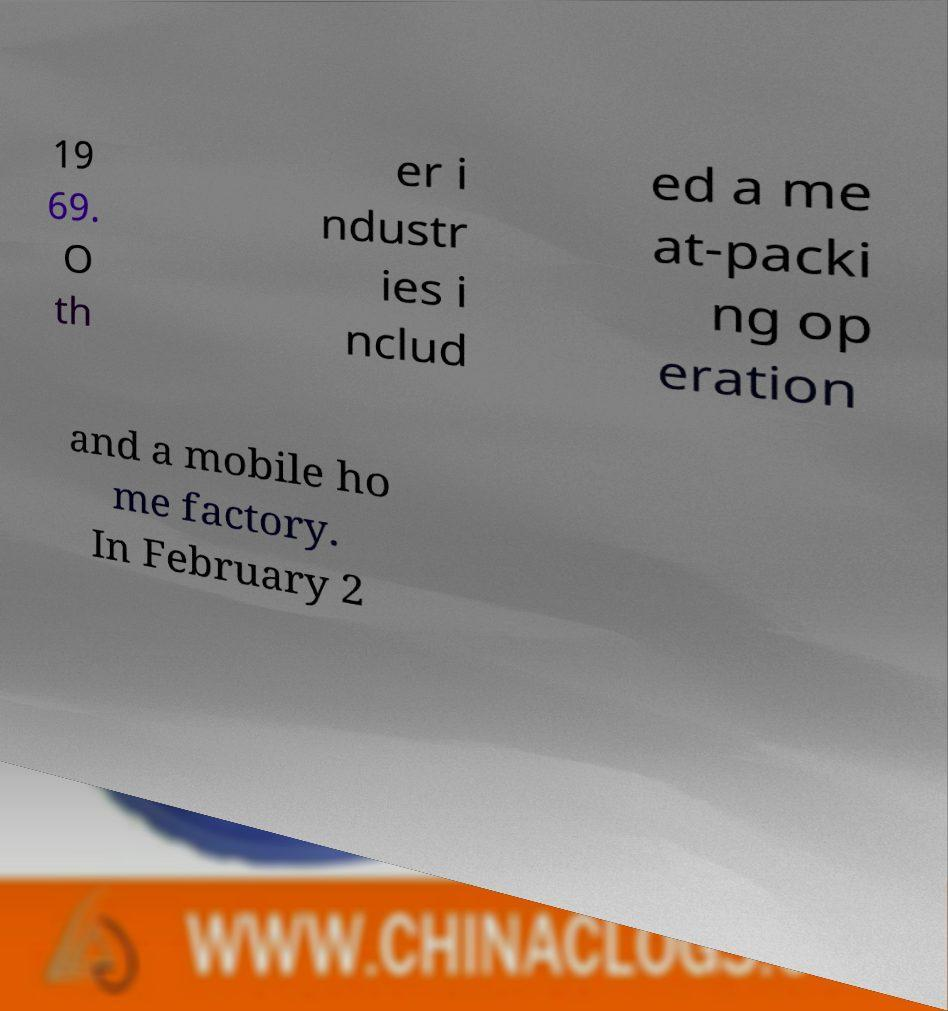Could you extract and type out the text from this image? 19 69. O th er i ndustr ies i nclud ed a me at-packi ng op eration and a mobile ho me factory. In February 2 